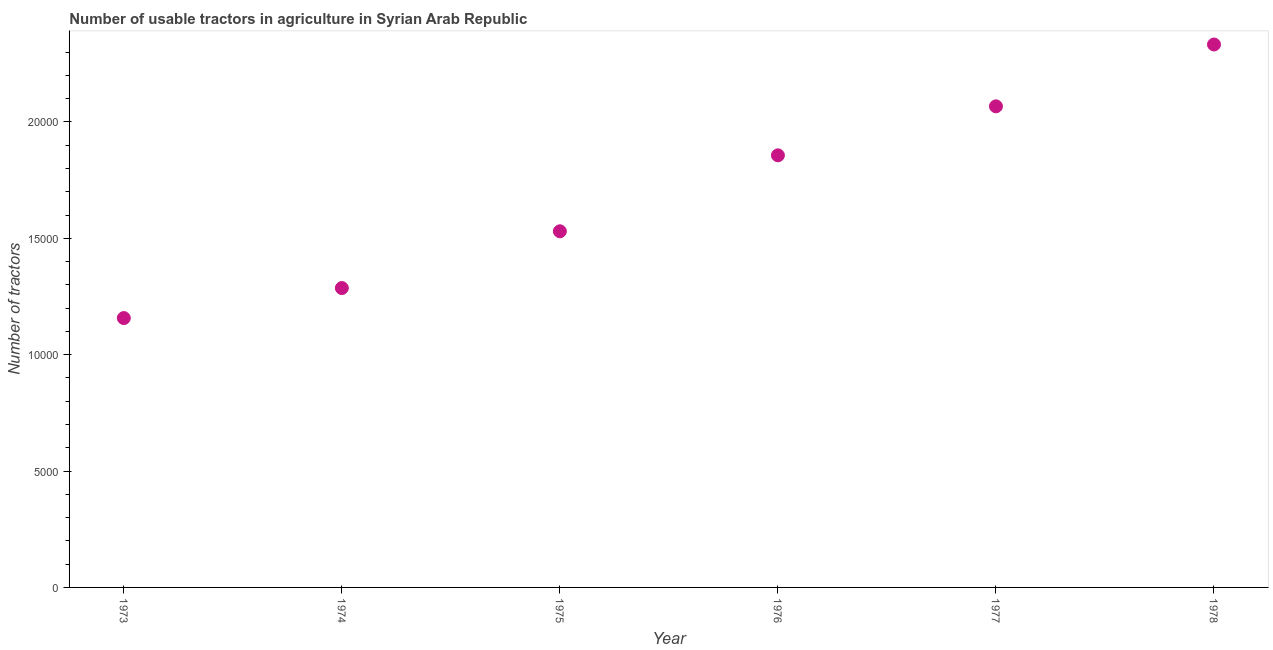What is the number of tractors in 1973?
Offer a very short reply. 1.16e+04. Across all years, what is the maximum number of tractors?
Your response must be concise. 2.33e+04. Across all years, what is the minimum number of tractors?
Your answer should be compact. 1.16e+04. In which year was the number of tractors maximum?
Your answer should be compact. 1978. In which year was the number of tractors minimum?
Your answer should be very brief. 1973. What is the sum of the number of tractors?
Provide a short and direct response. 1.02e+05. What is the difference between the number of tractors in 1973 and 1977?
Your response must be concise. -9098. What is the average number of tractors per year?
Keep it short and to the point. 1.71e+04. What is the median number of tractors?
Keep it short and to the point. 1.69e+04. In how many years, is the number of tractors greater than 5000 ?
Provide a succinct answer. 6. Do a majority of the years between 1978 and 1973 (inclusive) have number of tractors greater than 7000 ?
Your response must be concise. Yes. What is the ratio of the number of tractors in 1973 to that in 1976?
Ensure brevity in your answer.  0.62. Is the number of tractors in 1975 less than that in 1976?
Offer a terse response. Yes. What is the difference between the highest and the second highest number of tractors?
Your response must be concise. 2657. What is the difference between the highest and the lowest number of tractors?
Your answer should be compact. 1.18e+04. Does the number of tractors monotonically increase over the years?
Offer a very short reply. Yes. How many dotlines are there?
Make the answer very short. 1. What is the difference between two consecutive major ticks on the Y-axis?
Provide a short and direct response. 5000. Does the graph contain any zero values?
Your answer should be very brief. No. What is the title of the graph?
Your answer should be compact. Number of usable tractors in agriculture in Syrian Arab Republic. What is the label or title of the Y-axis?
Your answer should be very brief. Number of tractors. What is the Number of tractors in 1973?
Provide a short and direct response. 1.16e+04. What is the Number of tractors in 1974?
Your answer should be very brief. 1.29e+04. What is the Number of tractors in 1975?
Offer a terse response. 1.53e+04. What is the Number of tractors in 1976?
Provide a succinct answer. 1.86e+04. What is the Number of tractors in 1977?
Give a very brief answer. 2.07e+04. What is the Number of tractors in 1978?
Give a very brief answer. 2.33e+04. What is the difference between the Number of tractors in 1973 and 1974?
Give a very brief answer. -1290. What is the difference between the Number of tractors in 1973 and 1975?
Offer a terse response. -3729. What is the difference between the Number of tractors in 1973 and 1976?
Give a very brief answer. -6993. What is the difference between the Number of tractors in 1973 and 1977?
Provide a short and direct response. -9098. What is the difference between the Number of tractors in 1973 and 1978?
Your answer should be very brief. -1.18e+04. What is the difference between the Number of tractors in 1974 and 1975?
Give a very brief answer. -2439. What is the difference between the Number of tractors in 1974 and 1976?
Offer a terse response. -5703. What is the difference between the Number of tractors in 1974 and 1977?
Your response must be concise. -7808. What is the difference between the Number of tractors in 1974 and 1978?
Provide a short and direct response. -1.05e+04. What is the difference between the Number of tractors in 1975 and 1976?
Ensure brevity in your answer.  -3264. What is the difference between the Number of tractors in 1975 and 1977?
Ensure brevity in your answer.  -5369. What is the difference between the Number of tractors in 1975 and 1978?
Your answer should be compact. -8026. What is the difference between the Number of tractors in 1976 and 1977?
Your response must be concise. -2105. What is the difference between the Number of tractors in 1976 and 1978?
Ensure brevity in your answer.  -4762. What is the difference between the Number of tractors in 1977 and 1978?
Your response must be concise. -2657. What is the ratio of the Number of tractors in 1973 to that in 1974?
Provide a succinct answer. 0.9. What is the ratio of the Number of tractors in 1973 to that in 1975?
Provide a short and direct response. 0.76. What is the ratio of the Number of tractors in 1973 to that in 1976?
Provide a succinct answer. 0.62. What is the ratio of the Number of tractors in 1973 to that in 1977?
Give a very brief answer. 0.56. What is the ratio of the Number of tractors in 1973 to that in 1978?
Your response must be concise. 0.5. What is the ratio of the Number of tractors in 1974 to that in 1975?
Provide a succinct answer. 0.84. What is the ratio of the Number of tractors in 1974 to that in 1976?
Provide a succinct answer. 0.69. What is the ratio of the Number of tractors in 1974 to that in 1977?
Your answer should be very brief. 0.62. What is the ratio of the Number of tractors in 1974 to that in 1978?
Keep it short and to the point. 0.55. What is the ratio of the Number of tractors in 1975 to that in 1976?
Keep it short and to the point. 0.82. What is the ratio of the Number of tractors in 1975 to that in 1977?
Offer a very short reply. 0.74. What is the ratio of the Number of tractors in 1975 to that in 1978?
Offer a terse response. 0.66. What is the ratio of the Number of tractors in 1976 to that in 1977?
Your answer should be compact. 0.9. What is the ratio of the Number of tractors in 1976 to that in 1978?
Give a very brief answer. 0.8. What is the ratio of the Number of tractors in 1977 to that in 1978?
Ensure brevity in your answer.  0.89. 